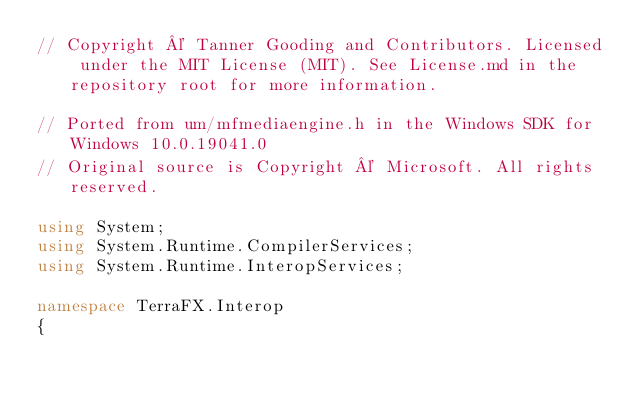<code> <loc_0><loc_0><loc_500><loc_500><_C#_>// Copyright © Tanner Gooding and Contributors. Licensed under the MIT License (MIT). See License.md in the repository root for more information.

// Ported from um/mfmediaengine.h in the Windows SDK for Windows 10.0.19041.0
// Original source is Copyright © Microsoft. All rights reserved.

using System;
using System.Runtime.CompilerServices;
using System.Runtime.InteropServices;

namespace TerraFX.Interop
{</code> 